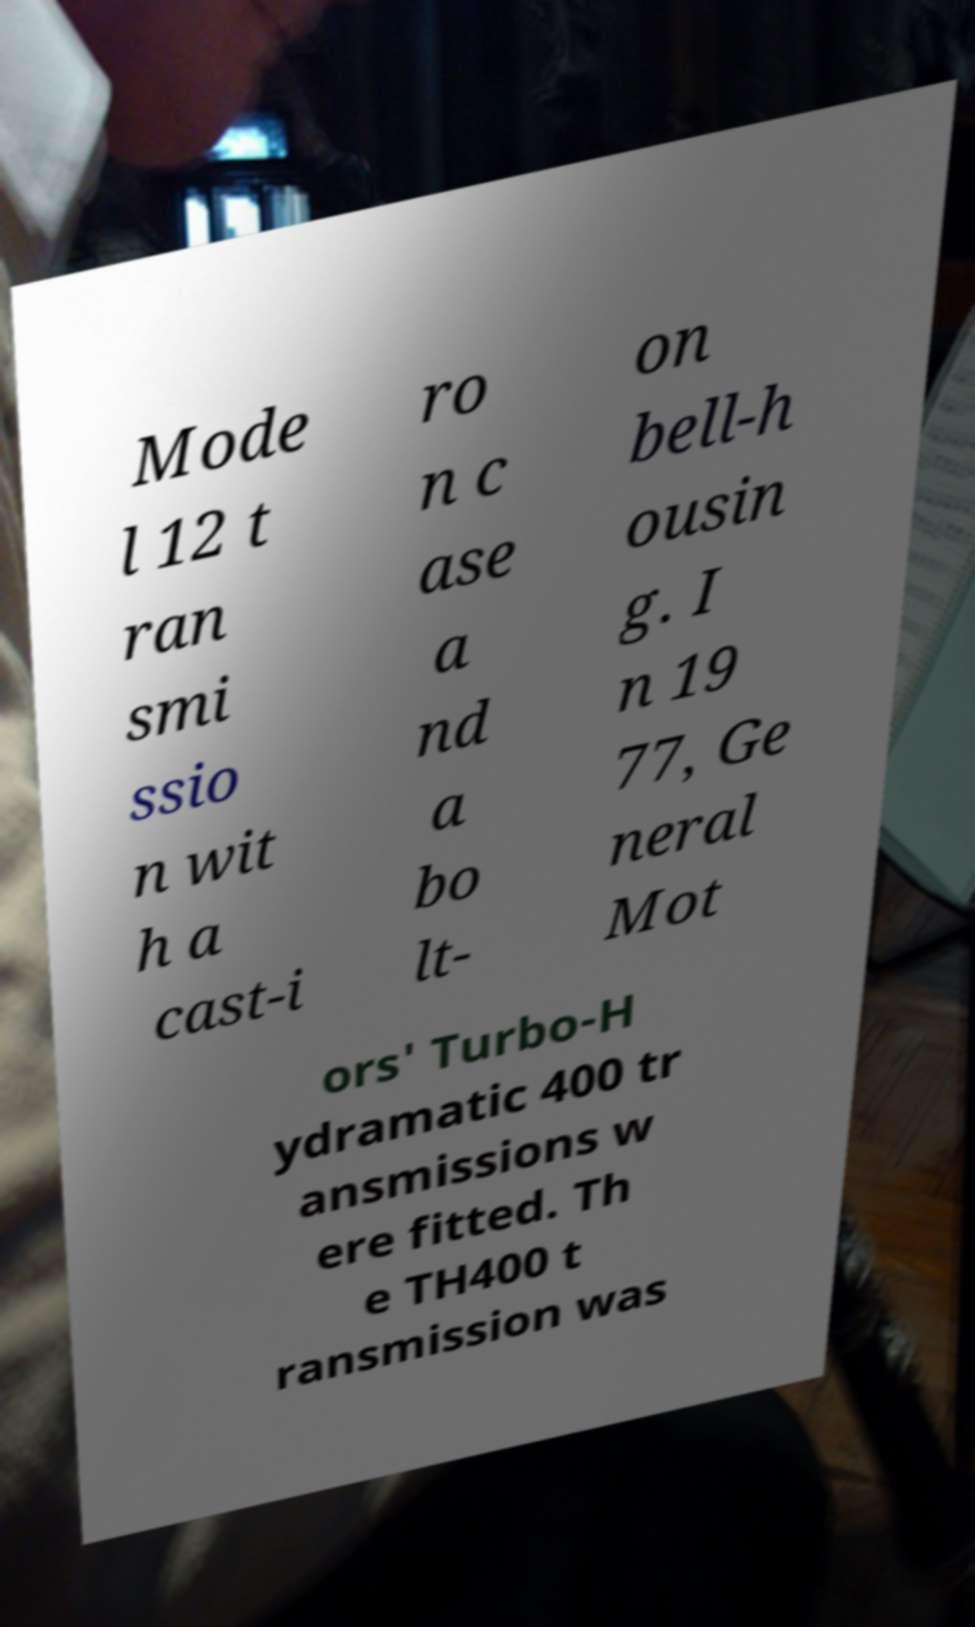Could you extract and type out the text from this image? Mode l 12 t ran smi ssio n wit h a cast-i ro n c ase a nd a bo lt- on bell-h ousin g. I n 19 77, Ge neral Mot ors' Turbo-H ydramatic 400 tr ansmissions w ere fitted. Th e TH400 t ransmission was 